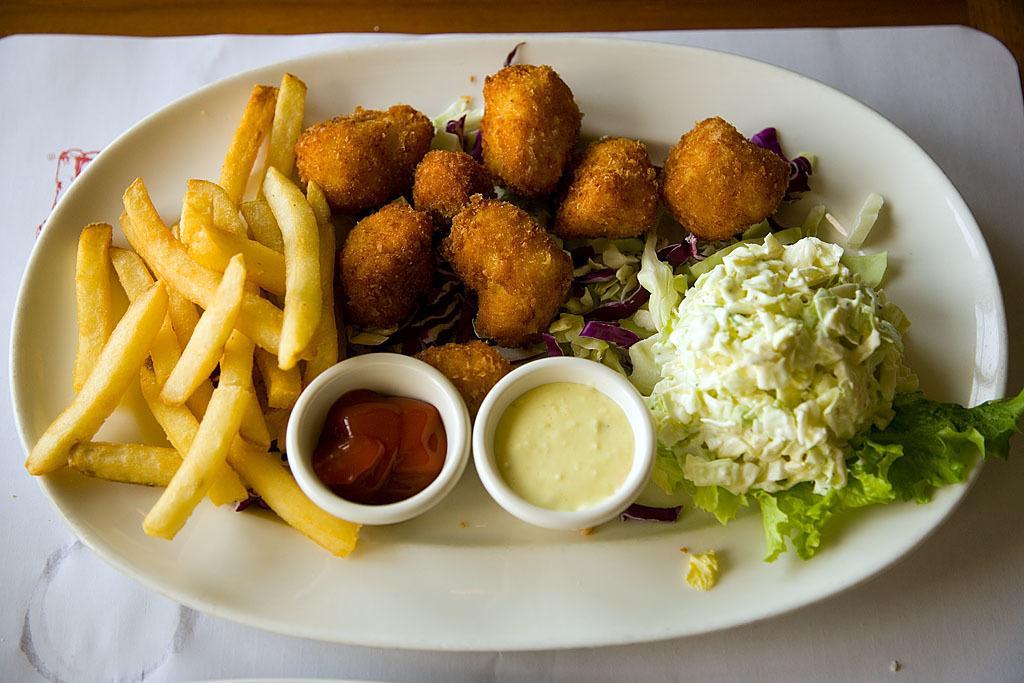Can you describe this image briefly? In this picture we can see french fries and other food in the plate. 